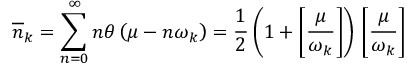<formula> <loc_0><loc_0><loc_500><loc_500>\overline { n } _ { k } = \sum _ { n = 0 } ^ { \infty } n \theta \left ( \mu - n \omega _ { k } \right ) = \frac { 1 } { 2 } \left ( 1 + \left [ \frac { \mu } { \omega _ { k } } \right ] \right ) \, \left [ \frac { \mu } { \omega _ { k } } \right ] \,</formula> 